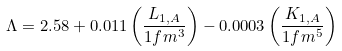<formula> <loc_0><loc_0><loc_500><loc_500>\Lambda = 2 . 5 8 + 0 . 0 1 1 \left ( { \frac { L _ { 1 , A } } { 1 f m ^ { 3 } } } \right ) - 0 . 0 0 0 3 \left ( { \frac { K _ { 1 , A } } { 1 f m ^ { 5 } } } \right )</formula> 